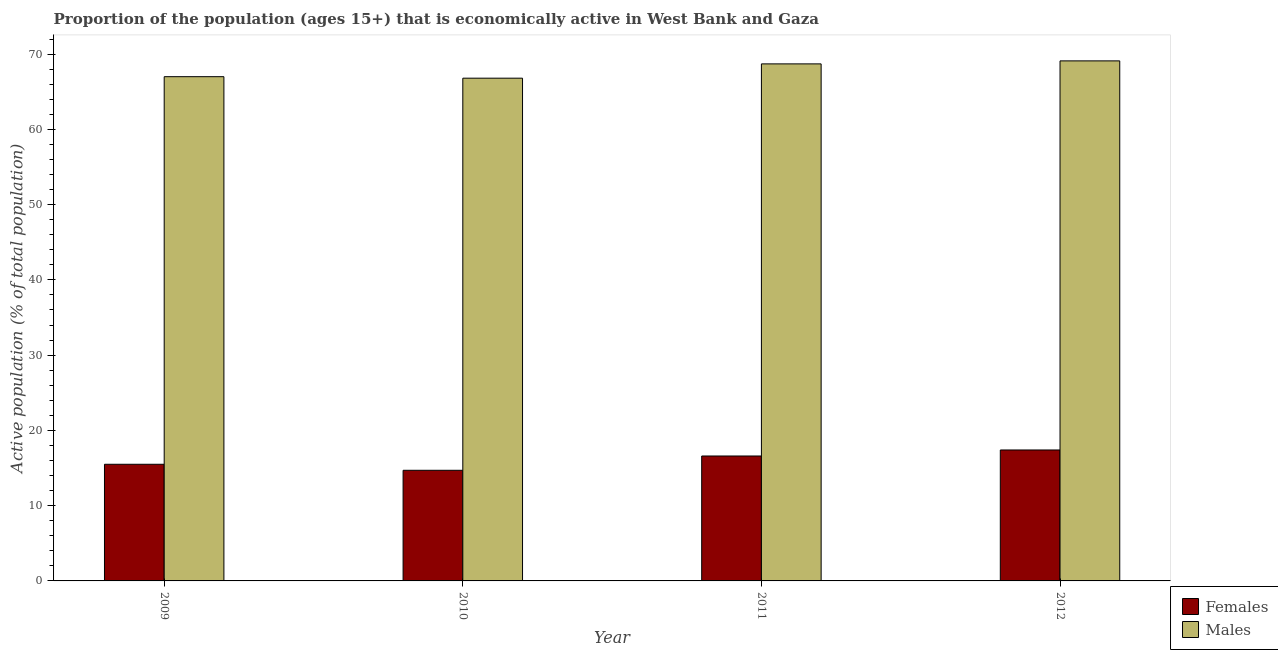How many different coloured bars are there?
Offer a terse response. 2. How many groups of bars are there?
Provide a succinct answer. 4. Are the number of bars per tick equal to the number of legend labels?
Make the answer very short. Yes. How many bars are there on the 2nd tick from the left?
Provide a succinct answer. 2. How many bars are there on the 2nd tick from the right?
Provide a short and direct response. 2. What is the label of the 1st group of bars from the left?
Offer a terse response. 2009. In how many cases, is the number of bars for a given year not equal to the number of legend labels?
Keep it short and to the point. 0. What is the percentage of economically active female population in 2012?
Give a very brief answer. 17.4. Across all years, what is the maximum percentage of economically active male population?
Make the answer very short. 69.1. Across all years, what is the minimum percentage of economically active male population?
Provide a succinct answer. 66.8. What is the total percentage of economically active male population in the graph?
Ensure brevity in your answer.  271.6. What is the difference between the percentage of economically active female population in 2010 and that in 2012?
Provide a succinct answer. -2.7. What is the difference between the percentage of economically active female population in 2011 and the percentage of economically active male population in 2009?
Provide a short and direct response. 1.1. What is the average percentage of economically active male population per year?
Ensure brevity in your answer.  67.9. In the year 2010, what is the difference between the percentage of economically active female population and percentage of economically active male population?
Ensure brevity in your answer.  0. What is the ratio of the percentage of economically active female population in 2010 to that in 2011?
Make the answer very short. 0.89. Is the percentage of economically active female population in 2009 less than that in 2012?
Provide a succinct answer. Yes. What is the difference between the highest and the second highest percentage of economically active male population?
Your response must be concise. 0.4. What is the difference between the highest and the lowest percentage of economically active female population?
Offer a terse response. 2.7. In how many years, is the percentage of economically active male population greater than the average percentage of economically active male population taken over all years?
Your answer should be very brief. 2. Is the sum of the percentage of economically active female population in 2009 and 2012 greater than the maximum percentage of economically active male population across all years?
Provide a short and direct response. Yes. What does the 2nd bar from the left in 2010 represents?
Your response must be concise. Males. What does the 1st bar from the right in 2009 represents?
Your response must be concise. Males. How many years are there in the graph?
Provide a short and direct response. 4. Does the graph contain any zero values?
Ensure brevity in your answer.  No. How many legend labels are there?
Your answer should be very brief. 2. What is the title of the graph?
Give a very brief answer. Proportion of the population (ages 15+) that is economically active in West Bank and Gaza. What is the label or title of the X-axis?
Make the answer very short. Year. What is the label or title of the Y-axis?
Ensure brevity in your answer.  Active population (% of total population). What is the Active population (% of total population) of Males in 2009?
Provide a succinct answer. 67. What is the Active population (% of total population) in Females in 2010?
Make the answer very short. 14.7. What is the Active population (% of total population) of Males in 2010?
Keep it short and to the point. 66.8. What is the Active population (% of total population) in Females in 2011?
Ensure brevity in your answer.  16.6. What is the Active population (% of total population) in Males in 2011?
Give a very brief answer. 68.7. What is the Active population (% of total population) of Females in 2012?
Your response must be concise. 17.4. What is the Active population (% of total population) in Males in 2012?
Provide a short and direct response. 69.1. Across all years, what is the maximum Active population (% of total population) in Females?
Offer a very short reply. 17.4. Across all years, what is the maximum Active population (% of total population) in Males?
Your response must be concise. 69.1. Across all years, what is the minimum Active population (% of total population) of Females?
Your response must be concise. 14.7. Across all years, what is the minimum Active population (% of total population) in Males?
Give a very brief answer. 66.8. What is the total Active population (% of total population) of Females in the graph?
Your response must be concise. 64.2. What is the total Active population (% of total population) of Males in the graph?
Your response must be concise. 271.6. What is the difference between the Active population (% of total population) in Males in 2009 and that in 2010?
Offer a very short reply. 0.2. What is the difference between the Active population (% of total population) in Females in 2009 and that in 2011?
Your answer should be compact. -1.1. What is the difference between the Active population (% of total population) of Males in 2009 and that in 2011?
Your answer should be very brief. -1.7. What is the difference between the Active population (% of total population) in Males in 2009 and that in 2012?
Make the answer very short. -2.1. What is the difference between the Active population (% of total population) in Females in 2010 and that in 2011?
Offer a very short reply. -1.9. What is the difference between the Active population (% of total population) of Males in 2010 and that in 2012?
Ensure brevity in your answer.  -2.3. What is the difference between the Active population (% of total population) in Females in 2011 and that in 2012?
Provide a short and direct response. -0.8. What is the difference between the Active population (% of total population) in Females in 2009 and the Active population (% of total population) in Males in 2010?
Your answer should be compact. -51.3. What is the difference between the Active population (% of total population) of Females in 2009 and the Active population (% of total population) of Males in 2011?
Offer a terse response. -53.2. What is the difference between the Active population (% of total population) in Females in 2009 and the Active population (% of total population) in Males in 2012?
Your answer should be compact. -53.6. What is the difference between the Active population (% of total population) of Females in 2010 and the Active population (% of total population) of Males in 2011?
Make the answer very short. -54. What is the difference between the Active population (% of total population) of Females in 2010 and the Active population (% of total population) of Males in 2012?
Your answer should be compact. -54.4. What is the difference between the Active population (% of total population) of Females in 2011 and the Active population (% of total population) of Males in 2012?
Provide a short and direct response. -52.5. What is the average Active population (% of total population) of Females per year?
Your answer should be compact. 16.05. What is the average Active population (% of total population) of Males per year?
Provide a succinct answer. 67.9. In the year 2009, what is the difference between the Active population (% of total population) in Females and Active population (% of total population) in Males?
Make the answer very short. -51.5. In the year 2010, what is the difference between the Active population (% of total population) in Females and Active population (% of total population) in Males?
Offer a terse response. -52.1. In the year 2011, what is the difference between the Active population (% of total population) in Females and Active population (% of total population) in Males?
Give a very brief answer. -52.1. In the year 2012, what is the difference between the Active population (% of total population) in Females and Active population (% of total population) in Males?
Make the answer very short. -51.7. What is the ratio of the Active population (% of total population) of Females in 2009 to that in 2010?
Your answer should be compact. 1.05. What is the ratio of the Active population (% of total population) in Males in 2009 to that in 2010?
Make the answer very short. 1. What is the ratio of the Active population (% of total population) of Females in 2009 to that in 2011?
Your answer should be compact. 0.93. What is the ratio of the Active population (% of total population) in Males in 2009 to that in 2011?
Ensure brevity in your answer.  0.98. What is the ratio of the Active population (% of total population) of Females in 2009 to that in 2012?
Your answer should be very brief. 0.89. What is the ratio of the Active population (% of total population) in Males in 2009 to that in 2012?
Give a very brief answer. 0.97. What is the ratio of the Active population (% of total population) in Females in 2010 to that in 2011?
Your response must be concise. 0.89. What is the ratio of the Active population (% of total population) in Males in 2010 to that in 2011?
Ensure brevity in your answer.  0.97. What is the ratio of the Active population (% of total population) of Females in 2010 to that in 2012?
Your answer should be compact. 0.84. What is the ratio of the Active population (% of total population) of Males in 2010 to that in 2012?
Keep it short and to the point. 0.97. What is the ratio of the Active population (% of total population) of Females in 2011 to that in 2012?
Give a very brief answer. 0.95. What is the ratio of the Active population (% of total population) in Males in 2011 to that in 2012?
Your answer should be very brief. 0.99. What is the difference between the highest and the second highest Active population (% of total population) in Males?
Your response must be concise. 0.4. 